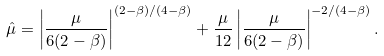<formula> <loc_0><loc_0><loc_500><loc_500>\hat { \mu } = \left | \frac { \mu } { 6 ( 2 - \beta ) } \right | ^ { ( 2 - \beta ) / ( 4 - \beta ) } + \frac { \mu } { 1 2 } \left | \frac { \mu } { 6 ( 2 - \beta ) } \right | ^ { - 2 / ( 4 - \beta ) } .</formula> 